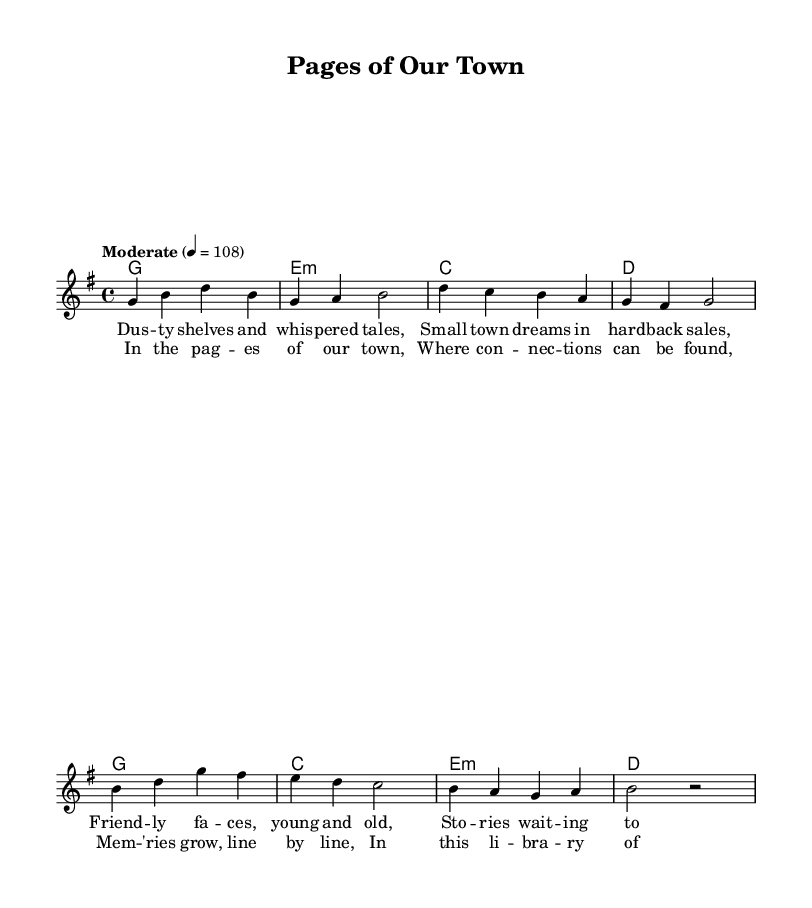What is the key signature of this music? The key signature displayed is G major, which has one sharp (F#).
Answer: G major What is the time signature of the piece? The time signature is indicated as 4/4, meaning there are four beats in each measure.
Answer: 4/4 What is the tempo marking for this piece? The tempo marking states "Moderate" with a metronome marking of 108 beats per minute.
Answer: Moderate How many measures are there in the verse section? By counting the measures in the melody part for the verse, there are four measures total.
Answer: Four What is the first chord in the verse? The first chord shown in the chord section for the verse is G major.
Answer: G What is the title of the song? The title of the song is displayed at the top as "Pages of Our Town."
Answer: Pages of Our Town What type of relationship do the lyrics depict in the chorus? The lyrics in the chorus focus on building connections within the community through memories formed at the library.
Answer: Connections 